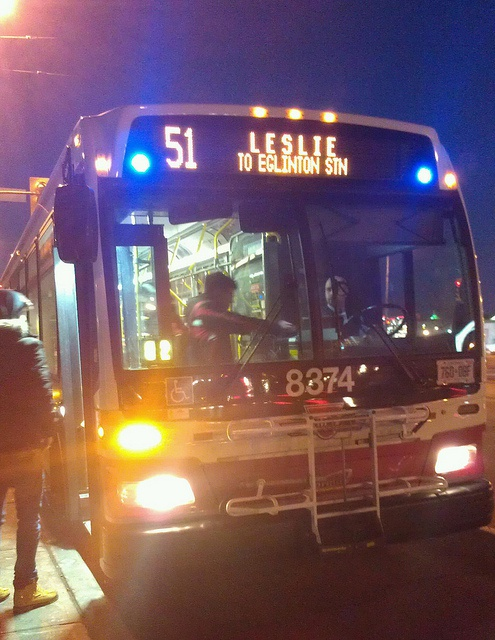Describe the objects in this image and their specific colors. I can see bus in ivory, brown, maroon, purple, and navy tones, people in ivory, brown, and maroon tones, people in ivory, brown, purple, and maroon tones, and people in ivory, purple, gray, and black tones in this image. 